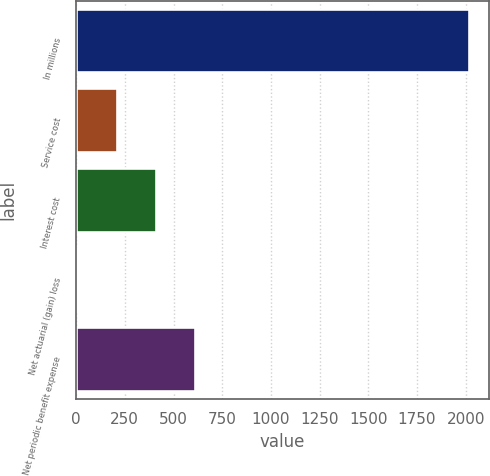<chart> <loc_0><loc_0><loc_500><loc_500><bar_chart><fcel>In millions<fcel>Service cost<fcel>Interest cost<fcel>Net actuarial (gain) loss<fcel>Net periodic benefit expense<nl><fcel>2017<fcel>209.89<fcel>410.68<fcel>9.1<fcel>611.47<nl></chart> 